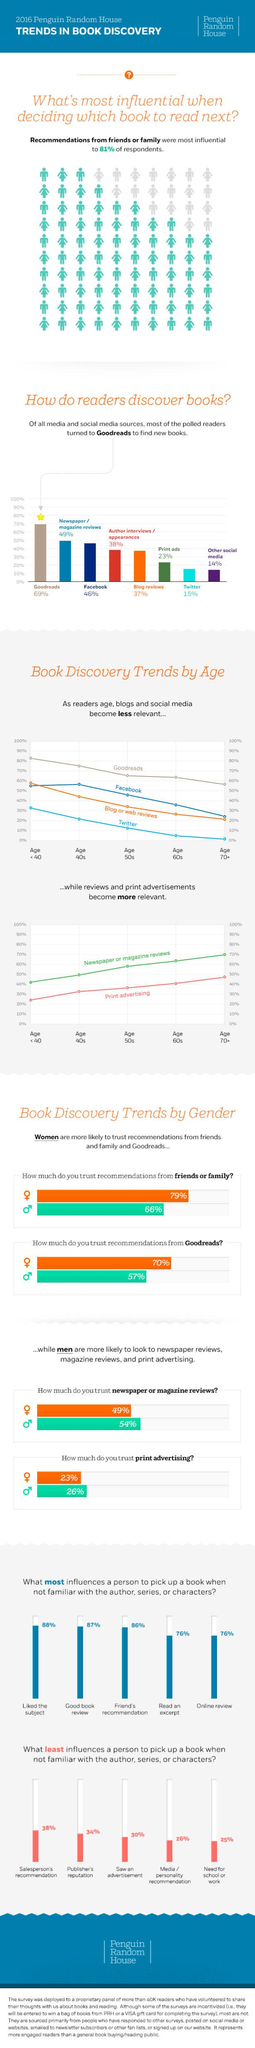Specify some key components in this picture. The combined influence of reading an excerpt and liking the subject on a person's decision to pick up a book is 164%. According to a study, 83% of readers discover books through Facebook and blog reviews. A significant percentage of online reviews, along with positive book reviews, influences a person's decision to pick up a book. According to a survey, 38% of readers discover books through both Twitter and print ads. Only 19% of respondents are not influenced by the recommendations of friends and family when deciding which book to read next, according to the survey. 